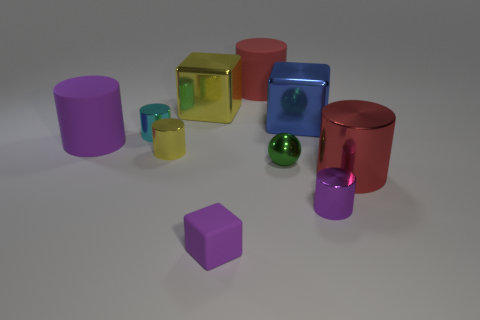There is a big object that is the same color as the tiny block; what is it made of?
Keep it short and to the point. Rubber. There is a rubber object that is the same color as the matte block; what size is it?
Make the answer very short. Large. How many metallic things are either brown balls or small cylinders?
Your response must be concise. 3. There is a small metal sphere in front of the red rubber object; is there a big metallic thing that is in front of it?
Make the answer very short. Yes. How many things are either things to the left of the large red matte object or big red objects in front of the purple rubber cylinder?
Ensure brevity in your answer.  6. Are there any other things that have the same color as the small matte object?
Your response must be concise. Yes. The large shiny object in front of the purple cylinder that is to the left of the red cylinder left of the green shiny sphere is what color?
Offer a terse response. Red. There is a cube to the right of the purple rubber thing in front of the tiny purple metal cylinder; what is its size?
Provide a succinct answer. Large. What is the large thing that is both on the left side of the rubber cube and in front of the big yellow object made of?
Provide a succinct answer. Rubber. There is a shiny sphere; is it the same size as the matte cylinder that is to the left of the small matte cube?
Your answer should be compact. No. 